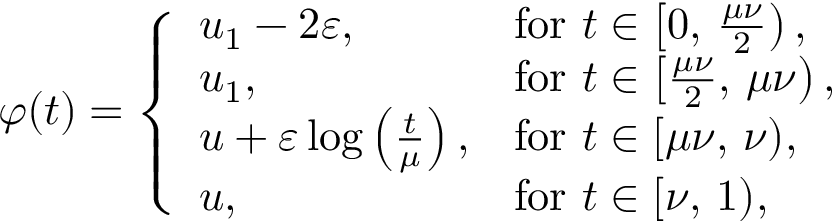<formula> <loc_0><loc_0><loc_500><loc_500>\varphi ( t ) = \left \{ \begin{array} { l l } { u _ { 1 } - 2 \varepsilon , } & { f o r t \in \left [ 0 , \, \frac { \mu \nu } { 2 } \right ) , } \\ { u _ { 1 } , } & { f o r t \in \left [ \frac { \mu \nu } { 2 } , \, \mu \nu \right ) , } \\ { u + \varepsilon \log \left ( \frac { t } { \mu } \right ) , } & { f o r t \in [ \mu \nu , \, \nu ) , } \\ { u , } & { f o r t \in [ \nu , \, 1 ) , } \end{array}</formula> 